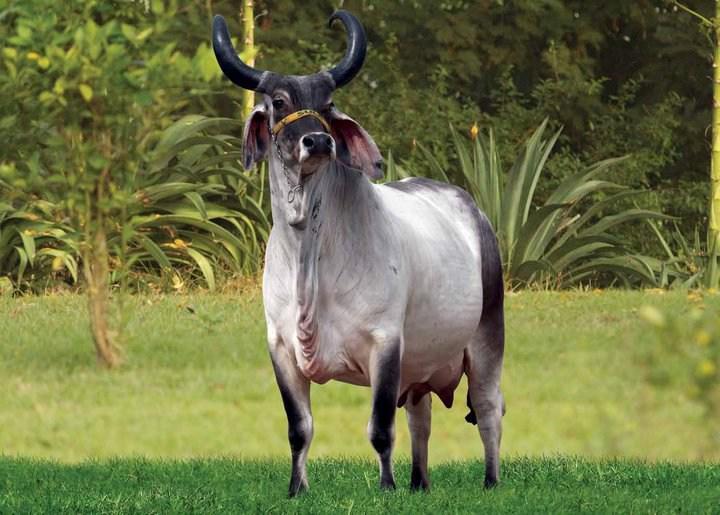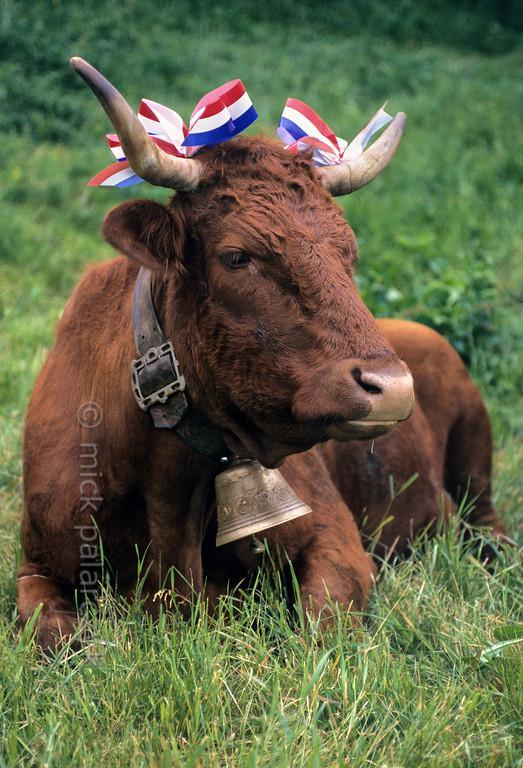The first image is the image on the left, the second image is the image on the right. For the images displayed, is the sentence "One of the animals is wearing decorations." factually correct? Answer yes or no. Yes. The first image is the image on the left, the second image is the image on the right. Considering the images on both sides, is "The right image contains one forward-facing ox with a somewhat lowered head, and the left image shows two look-alike oxen standing on green grass." valid? Answer yes or no. No. 